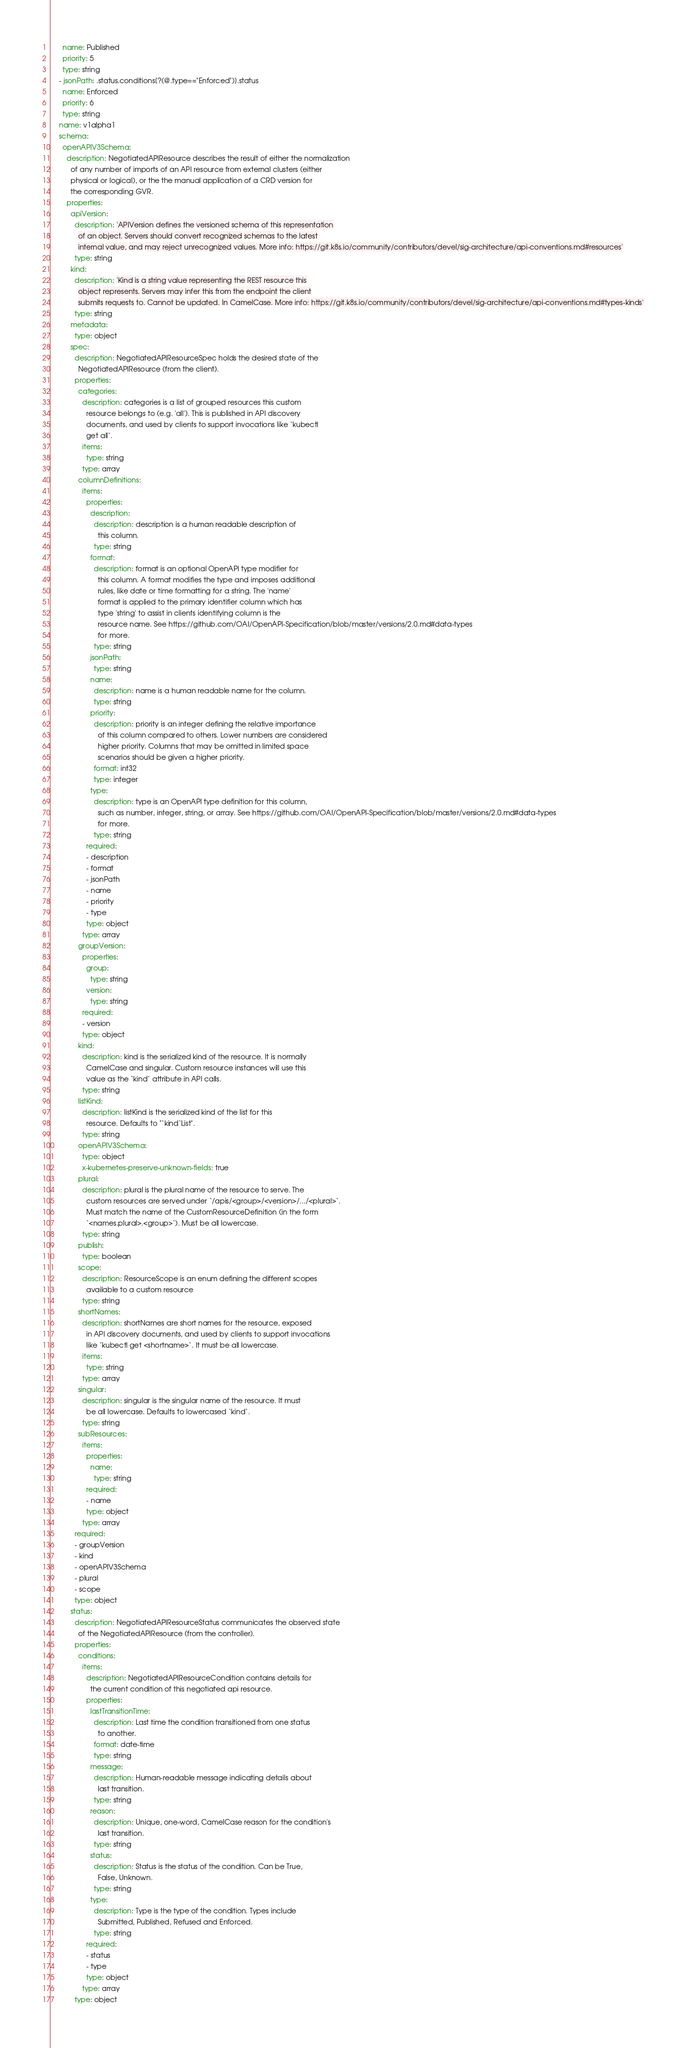Convert code to text. <code><loc_0><loc_0><loc_500><loc_500><_YAML_>      name: Published
      priority: 5
      type: string
    - jsonPath: .status.conditions[?(@.type=="Enforced")].status
      name: Enforced
      priority: 6
      type: string
    name: v1alpha1
    schema:
      openAPIV3Schema:
        description: NegotiatedAPIResource describes the result of either the normalization
          of any number of imports of an API resource from external clusters (either
          physical or logical), or the the manual application of a CRD version for
          the corresponding GVR.
        properties:
          apiVersion:
            description: 'APIVersion defines the versioned schema of this representation
              of an object. Servers should convert recognized schemas to the latest
              internal value, and may reject unrecognized values. More info: https://git.k8s.io/community/contributors/devel/sig-architecture/api-conventions.md#resources'
            type: string
          kind:
            description: 'Kind is a string value representing the REST resource this
              object represents. Servers may infer this from the endpoint the client
              submits requests to. Cannot be updated. In CamelCase. More info: https://git.k8s.io/community/contributors/devel/sig-architecture/api-conventions.md#types-kinds'
            type: string
          metadata:
            type: object
          spec:
            description: NegotiatedAPIResourceSpec holds the desired state of the
              NegotiatedAPIResource (from the client).
            properties:
              categories:
                description: categories is a list of grouped resources this custom
                  resource belongs to (e.g. 'all'). This is published in API discovery
                  documents, and used by clients to support invocations like `kubectl
                  get all`.
                items:
                  type: string
                type: array
              columnDefinitions:
                items:
                  properties:
                    description:
                      description: description is a human readable description of
                        this column.
                      type: string
                    format:
                      description: format is an optional OpenAPI type modifier for
                        this column. A format modifies the type and imposes additional
                        rules, like date or time formatting for a string. The 'name'
                        format is applied to the primary identifier column which has
                        type 'string' to assist in clients identifying column is the
                        resource name. See https://github.com/OAI/OpenAPI-Specification/blob/master/versions/2.0.md#data-types
                        for more.
                      type: string
                    jsonPath:
                      type: string
                    name:
                      description: name is a human readable name for the column.
                      type: string
                    priority:
                      description: priority is an integer defining the relative importance
                        of this column compared to others. Lower numbers are considered
                        higher priority. Columns that may be omitted in limited space
                        scenarios should be given a higher priority.
                      format: int32
                      type: integer
                    type:
                      description: type is an OpenAPI type definition for this column,
                        such as number, integer, string, or array. See https://github.com/OAI/OpenAPI-Specification/blob/master/versions/2.0.md#data-types
                        for more.
                      type: string
                  required:
                  - description
                  - format
                  - jsonPath
                  - name
                  - priority
                  - type
                  type: object
                type: array
              groupVersion:
                properties:
                  group:
                    type: string
                  version:
                    type: string
                required:
                - version
                type: object
              kind:
                description: kind is the serialized kind of the resource. It is normally
                  CamelCase and singular. Custom resource instances will use this
                  value as the `kind` attribute in API calls.
                type: string
              listKind:
                description: listKind is the serialized kind of the list for this
                  resource. Defaults to "`kind`List".
                type: string
              openAPIV3Schema:
                type: object
                x-kubernetes-preserve-unknown-fields: true
              plural:
                description: plural is the plural name of the resource to serve. The
                  custom resources are served under `/apis/<group>/<version>/.../<plural>`.
                  Must match the name of the CustomResourceDefinition (in the form
                  `<names.plural>.<group>`). Must be all lowercase.
                type: string
              publish:
                type: boolean
              scope:
                description: ResourceScope is an enum defining the different scopes
                  available to a custom resource
                type: string
              shortNames:
                description: shortNames are short names for the resource, exposed
                  in API discovery documents, and used by clients to support invocations
                  like `kubectl get <shortname>`. It must be all lowercase.
                items:
                  type: string
                type: array
              singular:
                description: singular is the singular name of the resource. It must
                  be all lowercase. Defaults to lowercased `kind`.
                type: string
              subResources:
                items:
                  properties:
                    name:
                      type: string
                  required:
                  - name
                  type: object
                type: array
            required:
            - groupVersion
            - kind
            - openAPIV3Schema
            - plural
            - scope
            type: object
          status:
            description: NegotiatedAPIResourceStatus communicates the observed state
              of the NegotiatedAPIResource (from the controller).
            properties:
              conditions:
                items:
                  description: NegotiatedAPIResourceCondition contains details for
                    the current condition of this negotiated api resource.
                  properties:
                    lastTransitionTime:
                      description: Last time the condition transitioned from one status
                        to another.
                      format: date-time
                      type: string
                    message:
                      description: Human-readable message indicating details about
                        last transition.
                      type: string
                    reason:
                      description: Unique, one-word, CamelCase reason for the condition's
                        last transition.
                      type: string
                    status:
                      description: Status is the status of the condition. Can be True,
                        False, Unknown.
                      type: string
                    type:
                      description: Type is the type of the condition. Types include
                        Submitted, Published, Refused and Enforced.
                      type: string
                  required:
                  - status
                  - type
                  type: object
                type: array
            type: object</code> 